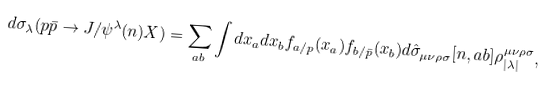<formula> <loc_0><loc_0><loc_500><loc_500>d \sigma _ { \lambda } ( p \bar { p } \to J / \psi ^ { \lambda } ( n ) X ) = \sum _ { a b } \int d x _ { a } d x _ { b } f _ { a / p } ( x _ { a } ) f _ { b / \bar { p } } ( x _ { b } ) d \hat { \sigma } _ { \mu \nu \rho \sigma } [ n , a b ] \rho _ { | \lambda | } ^ { \mu \nu \rho \sigma } ,</formula> 